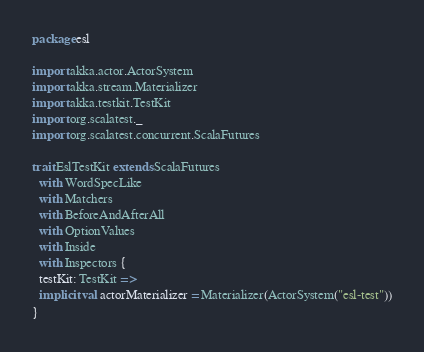Convert code to text. <code><loc_0><loc_0><loc_500><loc_500><_Scala_>package esl

import akka.actor.ActorSystem
import akka.stream.Materializer
import akka.testkit.TestKit
import org.scalatest._
import org.scalatest.concurrent.ScalaFutures

trait EslTestKit extends ScalaFutures
  with WordSpecLike
  with Matchers
  with BeforeAndAfterAll
  with OptionValues
  with Inside
  with Inspectors {
  testKit: TestKit =>
  implicit val actorMaterializer = Materializer(ActorSystem("esl-test"))
}
</code> 